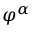<formula> <loc_0><loc_0><loc_500><loc_500>\varphi ^ { \alpha }</formula> 